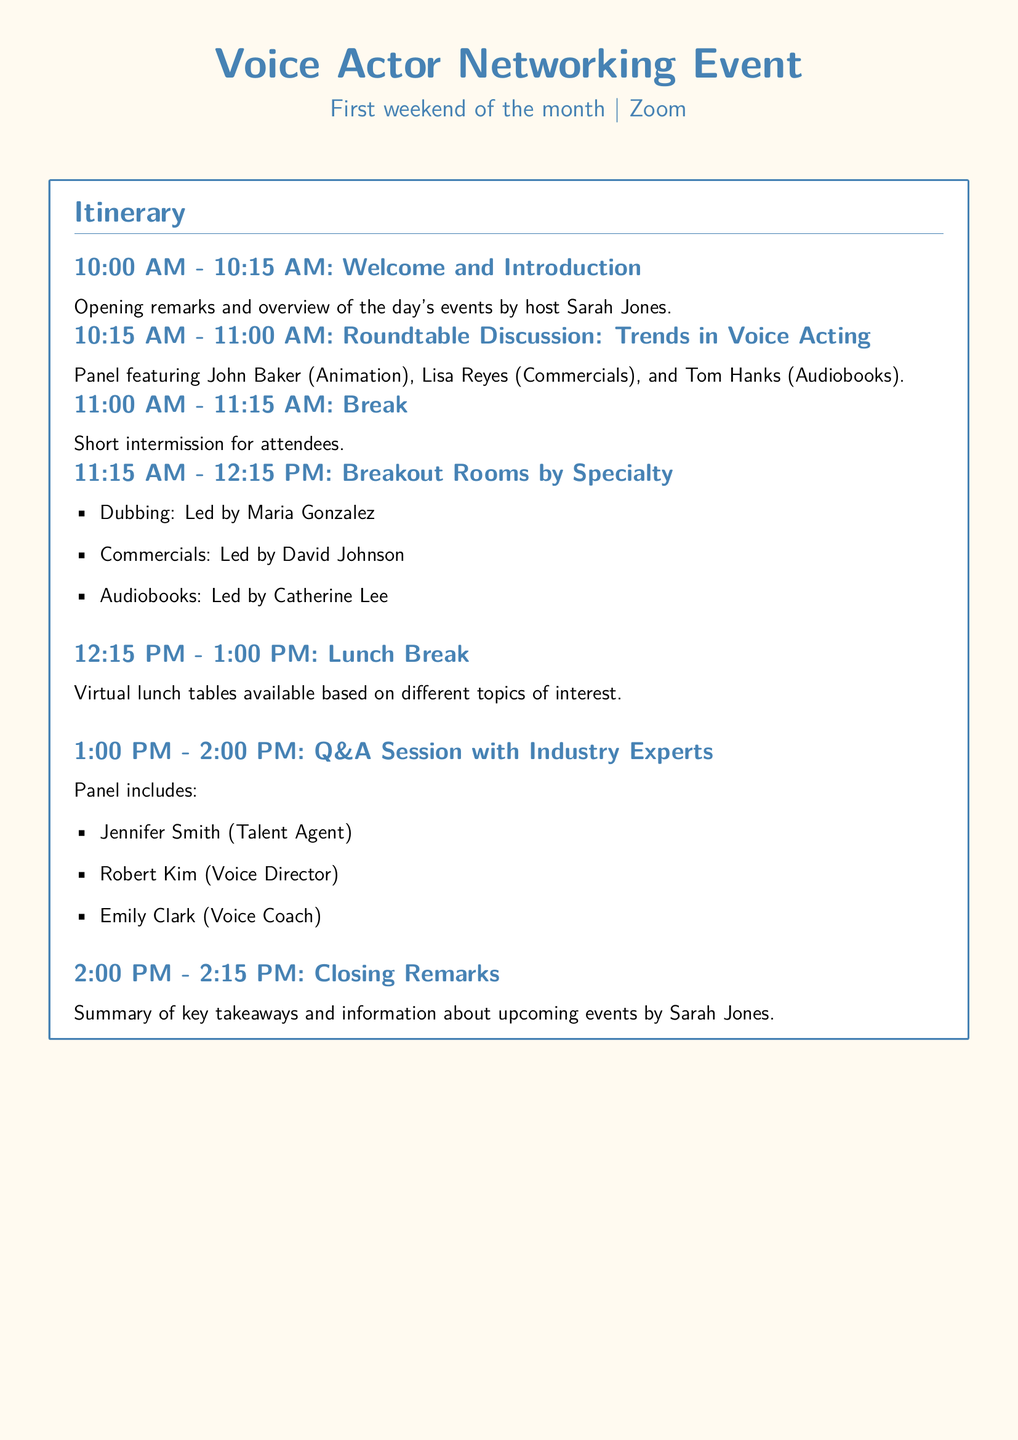What time does the event start? The event starts at 10:00 AM as indicated in the itinerary.
Answer: 10:00 AM Who is hosting the event? The host of the event is Sarah Jones, mentioned in the welcome section.
Answer: Sarah Jones How long is the roundtable discussion? The roundtable discussion lasts from 10:15 AM to 11:00 AM, which is 45 minutes.
Answer: 45 minutes Name one of the breakout room leaders. The document lists Maria Gonzalez as the leader for the Dubbing breakout room.
Answer: Maria Gonzalez What type of professionals are on the panel for the Q&A session? The panel for the Q&A session includes a talent agent, a voice director, and a voice coach.
Answer: Talent agent, voice director, voice coach At what time is the lunch break scheduled? The lunch break is scheduled from 12:15 PM to 1:00 PM.
Answer: 12:15 PM - 1:00 PM What is the total duration of the event? The event runs from 10:00 AM to 2:15 PM, which totals 4 hours and 15 minutes.
Answer: 4 hours and 15 minutes What is the focus of the breakout rooms? The breakout rooms are focused on different specialties in voice acting, as listed in the document.
Answer: Different specialties What will be discussed during the roundtable? The roundtable discussion will cover trends in voice acting.
Answer: Trends in voice acting 